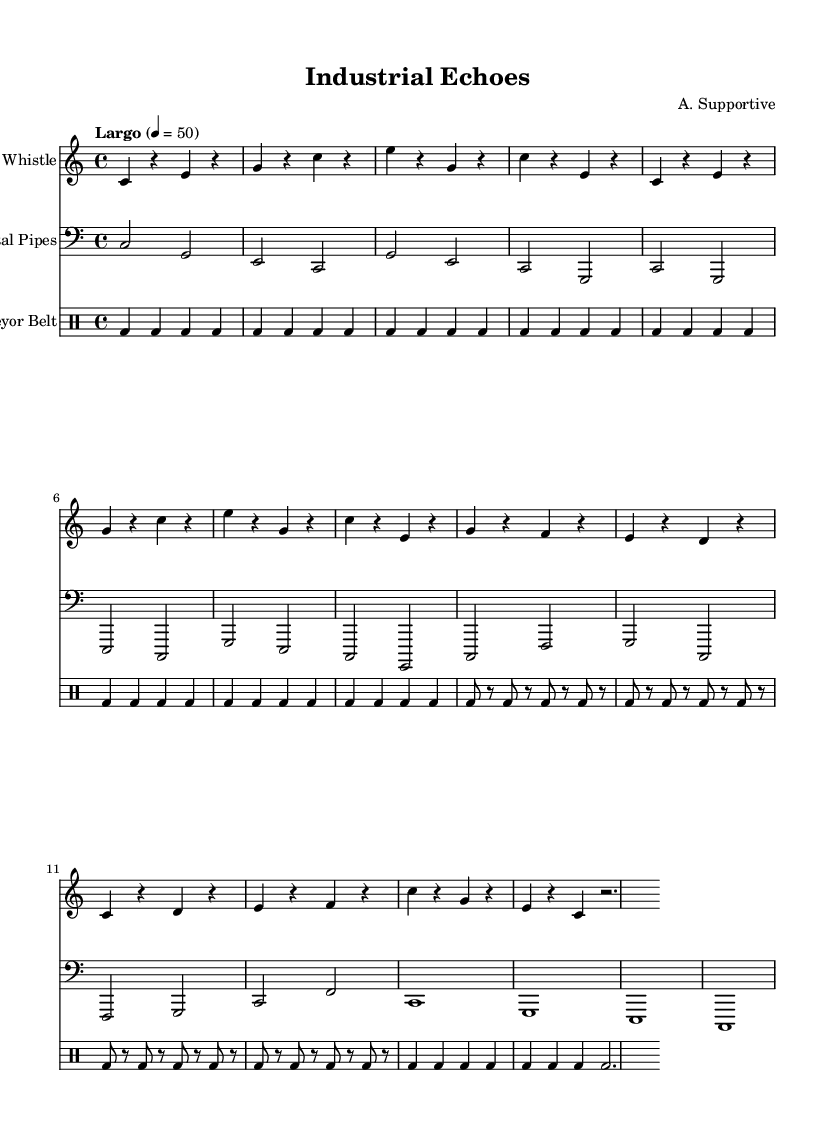What is the key signature of this music? The key signature is C major, which has no sharps or flats as indicated by the absence of any accidentals on the staff.
Answer: C major What is the time signature of this music? The time signature is 4/4, shown at the beginning of the score, indicating four beats per measure.
Answer: 4/4 What is the tempo marking of this piece? The tempo marking is "Largo," noted above the staves, indicating a slow tempo.
Answer: Largo How many measures are there for the Factory Whistle section? By counting the measures in the Factory Whistle part, there are a total of 8 measures, as indicated by the notation before the double bar line.
Answer: 8 Which instrument plays in the bass clef? The Metal Pipes section is denoted with bass clef at the beginning of its staff, indicating that it plays lower pitches compared to treble-clef instruments.
Answer: Metal Pipes What type of percussion instrument is indicated in the score? The drummode formatting indicates that the percussion section is for a bass drum, which is used consistently throughout the Conveyor Belt section.
Answer: Bass drum How does the use of industrial sounds enhance the composition? Industrial sounds in this context create an atmosphere that underscores minimalism, encouraging listeners to reflect on critical themes through repetitive and mechanical textures combined with human-like melodies.
Answer: Atmosphere 